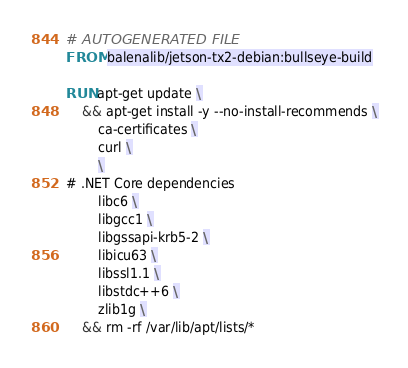Convert code to text. <code><loc_0><loc_0><loc_500><loc_500><_Dockerfile_># AUTOGENERATED FILE
FROM balenalib/jetson-tx2-debian:bullseye-build

RUN apt-get update \
    && apt-get install -y --no-install-recommends \
        ca-certificates \
        curl \
        \
# .NET Core dependencies
        libc6 \
        libgcc1 \
        libgssapi-krb5-2 \
        libicu63 \
        libssl1.1 \
        libstdc++6 \
        zlib1g \
    && rm -rf /var/lib/apt/lists/*
</code> 